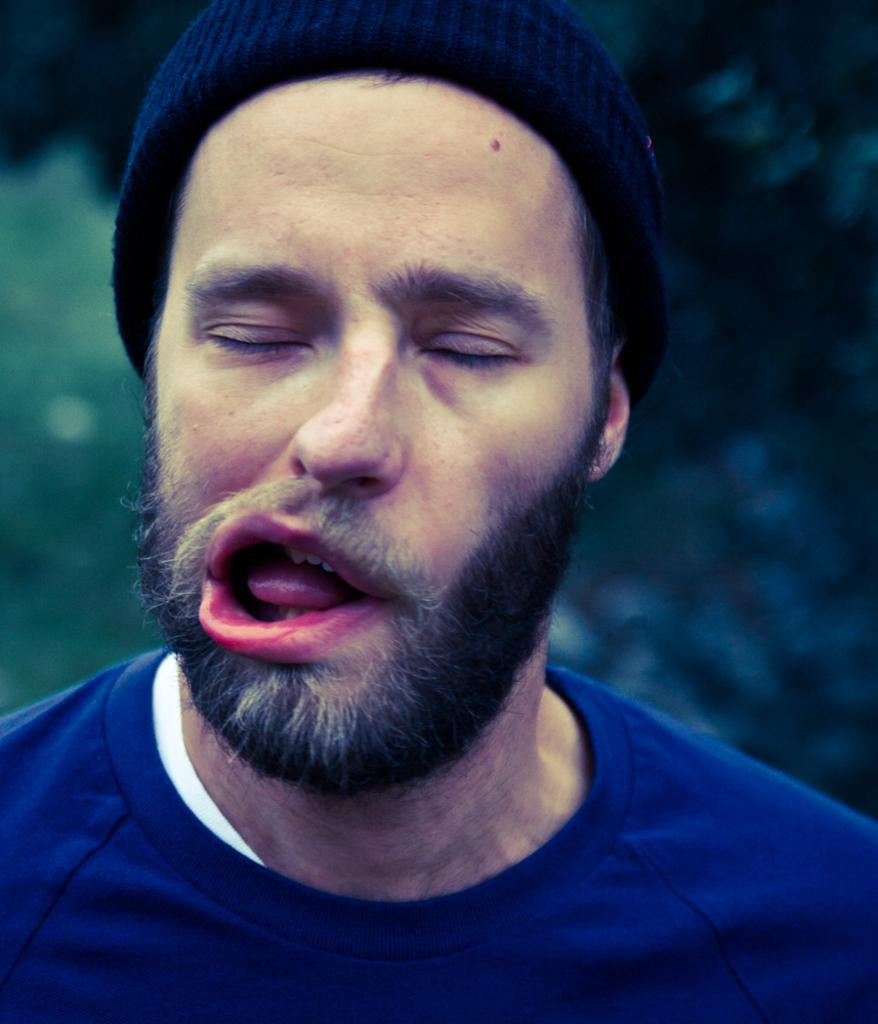Who is present in the image? There is a man in the image. What is the man wearing on his head? The man is wearing a cap on his head. Can you describe the background of the image? The background of the image is blurred. What type of lock is holding the curtain in the image? There is no lock or curtain present in the image. 